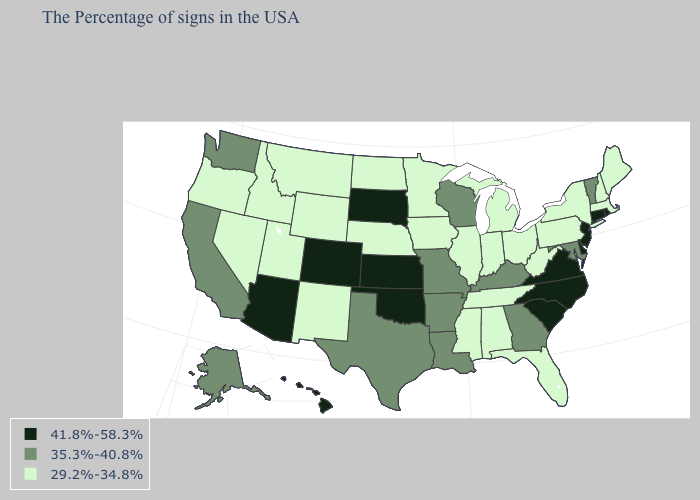Name the states that have a value in the range 41.8%-58.3%?
Concise answer only. Rhode Island, Connecticut, New Jersey, Delaware, Virginia, North Carolina, South Carolina, Kansas, Oklahoma, South Dakota, Colorado, Arizona, Hawaii. Does the map have missing data?
Short answer required. No. What is the value of Michigan?
Keep it brief. 29.2%-34.8%. What is the highest value in the West ?
Short answer required. 41.8%-58.3%. Name the states that have a value in the range 41.8%-58.3%?
Keep it brief. Rhode Island, Connecticut, New Jersey, Delaware, Virginia, North Carolina, South Carolina, Kansas, Oklahoma, South Dakota, Colorado, Arizona, Hawaii. What is the value of Wisconsin?
Be succinct. 35.3%-40.8%. What is the value of Idaho?
Short answer required. 29.2%-34.8%. What is the highest value in states that border Vermont?
Concise answer only. 29.2%-34.8%. Does South Dakota have the lowest value in the MidWest?
Keep it brief. No. What is the value of Oregon?
Short answer required. 29.2%-34.8%. Among the states that border Vermont , which have the highest value?
Keep it brief. Massachusetts, New Hampshire, New York. What is the value of West Virginia?
Write a very short answer. 29.2%-34.8%. Which states have the lowest value in the USA?
Write a very short answer. Maine, Massachusetts, New Hampshire, New York, Pennsylvania, West Virginia, Ohio, Florida, Michigan, Indiana, Alabama, Tennessee, Illinois, Mississippi, Minnesota, Iowa, Nebraska, North Dakota, Wyoming, New Mexico, Utah, Montana, Idaho, Nevada, Oregon. Does Minnesota have the lowest value in the MidWest?
Short answer required. Yes. 